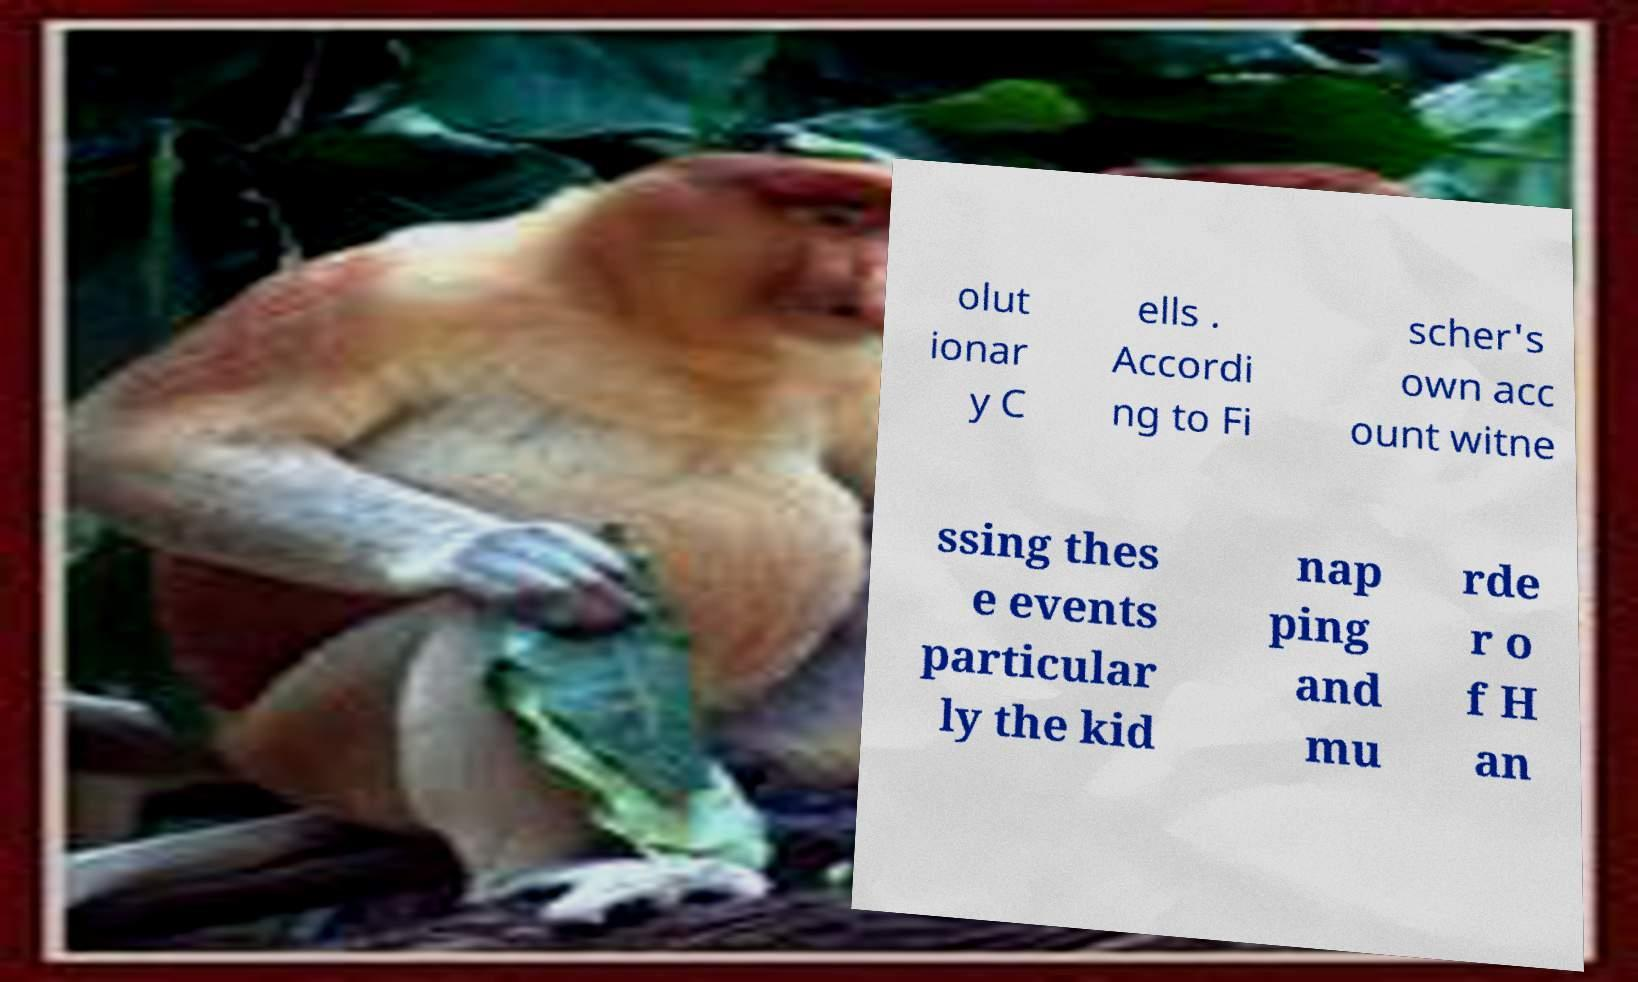What messages or text are displayed in this image? I need them in a readable, typed format. olut ionar y C ells . Accordi ng to Fi scher's own acc ount witne ssing thes e events particular ly the kid nap ping and mu rde r o f H an 